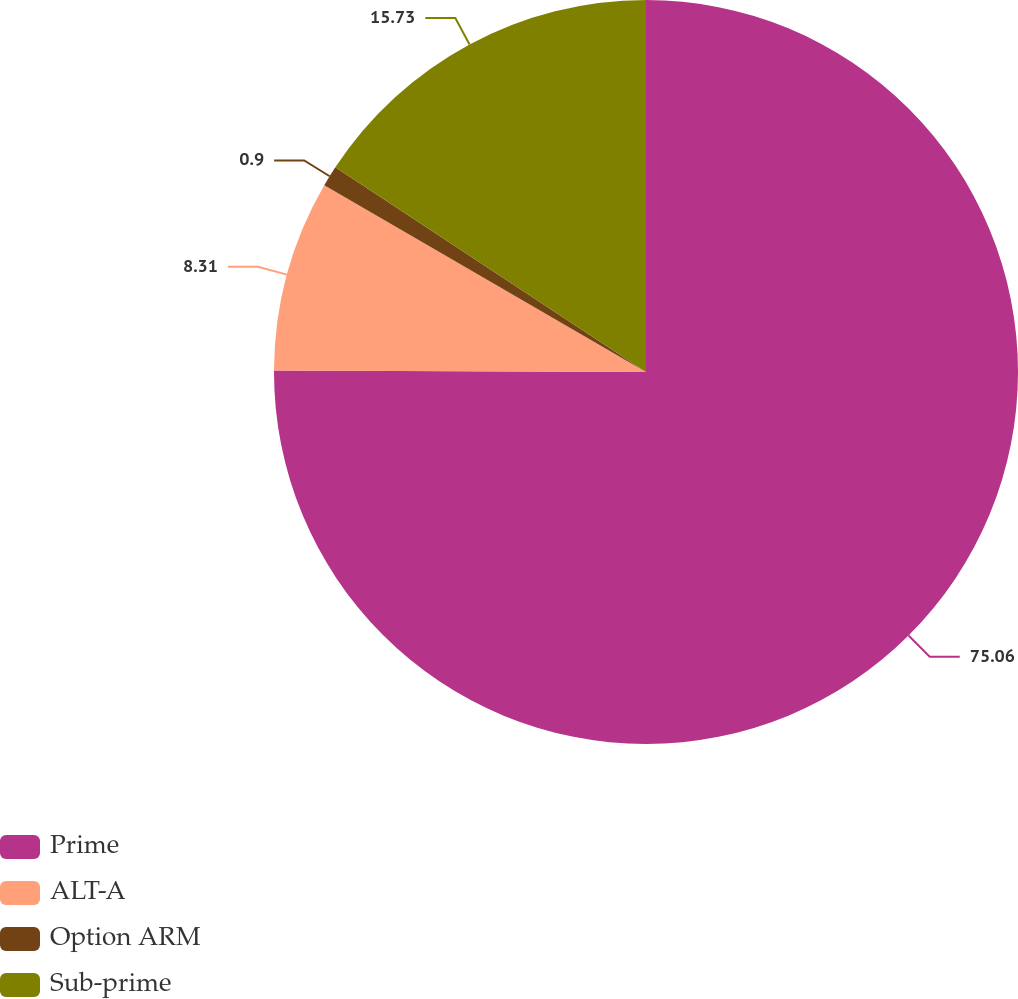Convert chart to OTSL. <chart><loc_0><loc_0><loc_500><loc_500><pie_chart><fcel>Prime<fcel>ALT-A<fcel>Option ARM<fcel>Sub-prime<nl><fcel>75.06%<fcel>8.31%<fcel>0.9%<fcel>15.73%<nl></chart> 